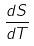<formula> <loc_0><loc_0><loc_500><loc_500>\frac { d S } { d T }</formula> 